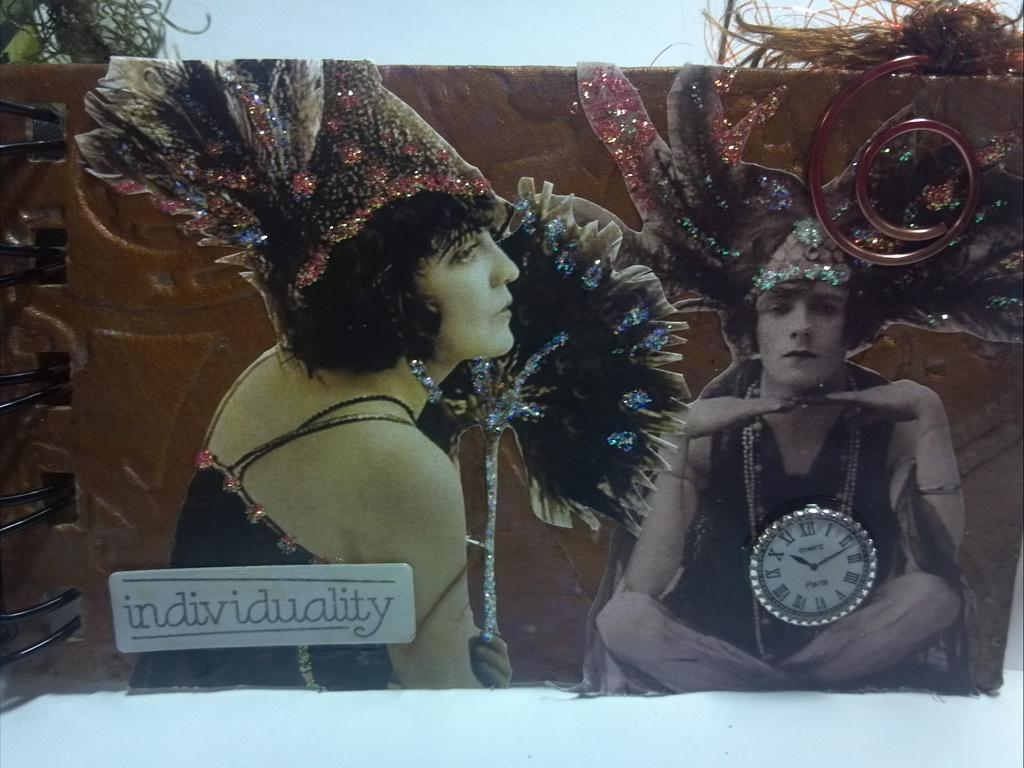<image>
Offer a succinct explanation of the picture presented. Board showing a person and a word that says "individuality" on it. 